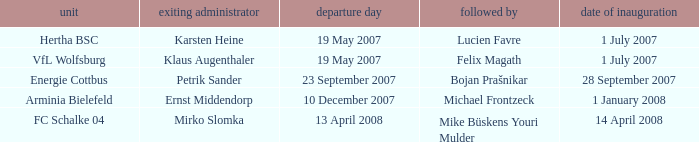When was the appointment date for the manager replaced by Lucien Favre? 1 July 2007. 